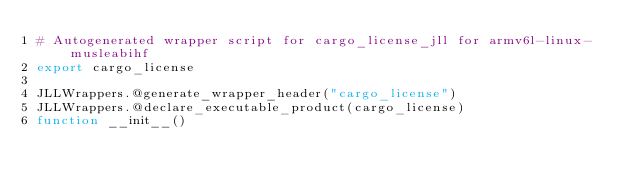Convert code to text. <code><loc_0><loc_0><loc_500><loc_500><_Julia_># Autogenerated wrapper script for cargo_license_jll for armv6l-linux-musleabihf
export cargo_license

JLLWrappers.@generate_wrapper_header("cargo_license")
JLLWrappers.@declare_executable_product(cargo_license)
function __init__()</code> 